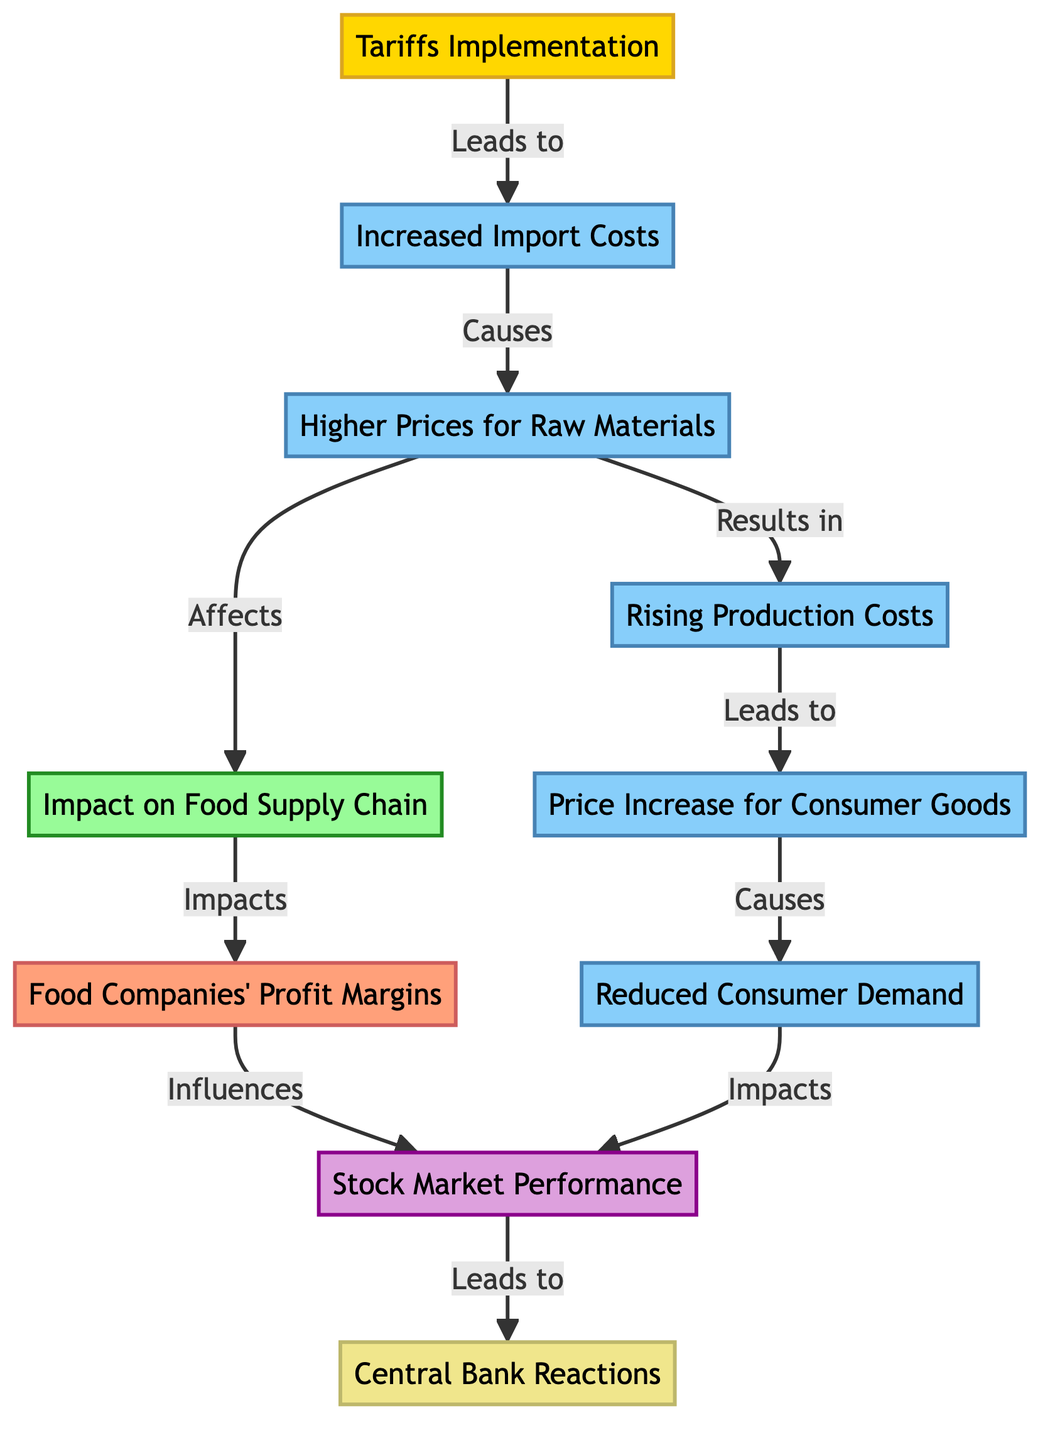What is the first event in the diagram? The first event indicated in the diagram is represented by the node labeled "Tariffs Implementation." This is the starting point of the flowchart, leading to the subsequent consequences.
Answer: Tariffs Implementation What consequence directly follows increased import costs? After the node labeled "Increased Import Costs," the next node in the chain is "Higher Prices for Raw Materials." This indicates a direct relationship between these two nodes.
Answer: Higher Prices for Raw Materials How many total nodes are in the diagram? The diagram contains a total of 10 nodes. This includes events, consequences, sectors, companies, and indicators.
Answer: 10 What impact does reduced consumer demand have on stock market performance? The diagram illustrates that "Reduced Consumer Demand" directly impacts "Stock Market Performance." This means that changes in consumer demand can influence how stocks perform in the market.
Answer: Impacts Which node is affected by rising production costs? "Rising Production Costs" leads to "Price Increase for Consumer Goods" in the diagram. This shows that increased production expenses can subsequently raise consumer prices.
Answer: Price Increase for Consumer Goods What is the last consequence that leads to central bank reactions? The final consequence that leads to "Central Bank Reactions" is "Stock Market Performance." Thus, any changes in stock market performance, whether positive or negative, may prompt a response from the central bank.
Answer: Stock Market Performance Which two nodes are connected by the phrase "Affects"? The phrase "Affects" connects "Higher Prices for Raw Materials" to "Impact on Food Supply Chain." This denotes a relationship where increasing raw material prices have an influence on the food supply sector.
Answer: Impact on Food Supply Chain What is the relationship between food companies' profit margins and stock market performance? According to the diagram, "Food Companies' Profit Margins" influence "Stock Market Performance." This indicates that the profitability of food companies can affect how they are valued in the stock market.
Answer: Influences 